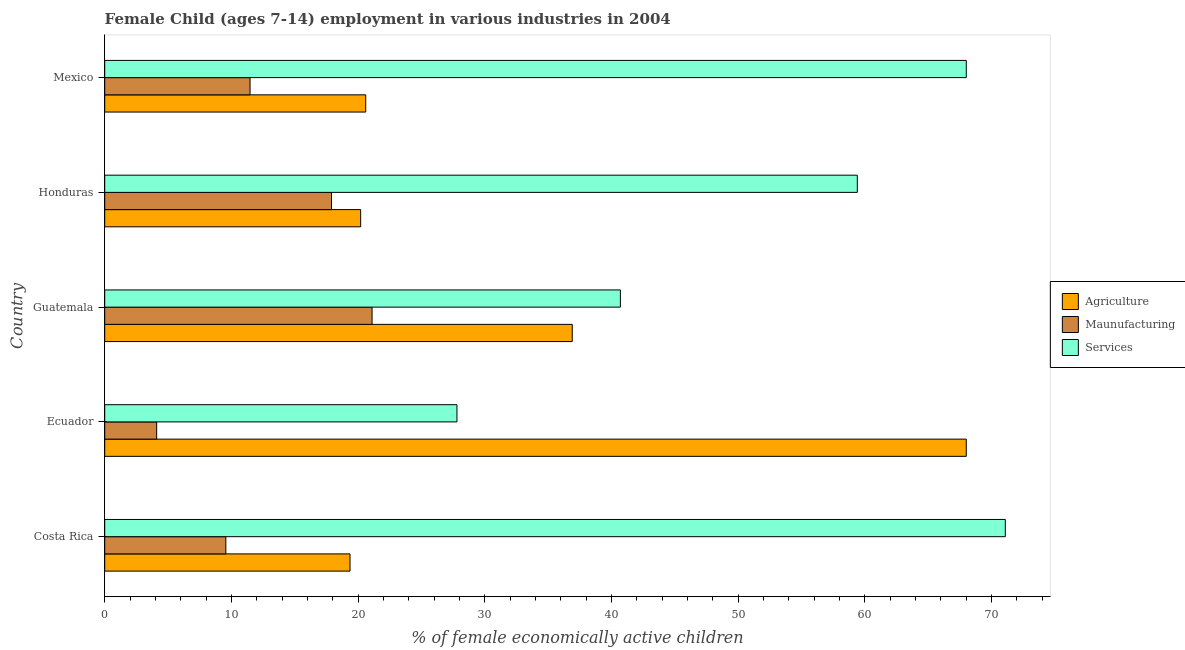How many groups of bars are there?
Offer a terse response. 5. Are the number of bars per tick equal to the number of legend labels?
Make the answer very short. Yes. Are the number of bars on each tick of the Y-axis equal?
Offer a very short reply. Yes. How many bars are there on the 1st tick from the bottom?
Provide a succinct answer. 3. What is the label of the 4th group of bars from the top?
Provide a short and direct response. Ecuador. What is the percentage of economically active children in agriculture in Mexico?
Your answer should be very brief. 20.6. Across all countries, what is the maximum percentage of economically active children in services?
Give a very brief answer. 71.08. Across all countries, what is the minimum percentage of economically active children in services?
Your answer should be compact. 27.8. In which country was the percentage of economically active children in manufacturing maximum?
Give a very brief answer. Guatemala. In which country was the percentage of economically active children in manufacturing minimum?
Your answer should be very brief. Ecuador. What is the total percentage of economically active children in agriculture in the graph?
Your answer should be compact. 165.06. What is the difference between the percentage of economically active children in agriculture in Costa Rica and that in Honduras?
Your answer should be compact. -0.84. What is the difference between the percentage of economically active children in agriculture in Ecuador and the percentage of economically active children in manufacturing in Guatemala?
Make the answer very short. 46.9. What is the average percentage of economically active children in services per country?
Your response must be concise. 53.4. What is the difference between the percentage of economically active children in services and percentage of economically active children in agriculture in Ecuador?
Provide a succinct answer. -40.2. What is the ratio of the percentage of economically active children in services in Costa Rica to that in Honduras?
Provide a succinct answer. 1.2. What is the difference between the highest and the second highest percentage of economically active children in services?
Keep it short and to the point. 3.08. What does the 3rd bar from the top in Guatemala represents?
Give a very brief answer. Agriculture. What does the 3rd bar from the bottom in Honduras represents?
Your answer should be very brief. Services. Are all the bars in the graph horizontal?
Your answer should be very brief. Yes. How many countries are there in the graph?
Your answer should be compact. 5. How many legend labels are there?
Your response must be concise. 3. What is the title of the graph?
Ensure brevity in your answer.  Female Child (ages 7-14) employment in various industries in 2004. Does "Taxes on goods and services" appear as one of the legend labels in the graph?
Your response must be concise. No. What is the label or title of the X-axis?
Provide a succinct answer. % of female economically active children. What is the % of female economically active children in Agriculture in Costa Rica?
Provide a succinct answer. 19.36. What is the % of female economically active children of Maunufacturing in Costa Rica?
Keep it short and to the point. 9.56. What is the % of female economically active children in Services in Costa Rica?
Your answer should be very brief. 71.08. What is the % of female economically active children of Services in Ecuador?
Make the answer very short. 27.8. What is the % of female economically active children of Agriculture in Guatemala?
Your answer should be very brief. 36.9. What is the % of female economically active children of Maunufacturing in Guatemala?
Provide a short and direct response. 21.1. What is the % of female economically active children in Services in Guatemala?
Your response must be concise. 40.7. What is the % of female economically active children of Agriculture in Honduras?
Give a very brief answer. 20.2. What is the % of female economically active children of Services in Honduras?
Your answer should be very brief. 59.4. What is the % of female economically active children of Agriculture in Mexico?
Provide a short and direct response. 20.6. What is the % of female economically active children in Maunufacturing in Mexico?
Your answer should be very brief. 11.47. What is the % of female economically active children in Services in Mexico?
Offer a terse response. 68. Across all countries, what is the maximum % of female economically active children of Agriculture?
Provide a short and direct response. 68. Across all countries, what is the maximum % of female economically active children in Maunufacturing?
Provide a short and direct response. 21.1. Across all countries, what is the maximum % of female economically active children of Services?
Keep it short and to the point. 71.08. Across all countries, what is the minimum % of female economically active children in Agriculture?
Provide a succinct answer. 19.36. Across all countries, what is the minimum % of female economically active children in Maunufacturing?
Provide a short and direct response. 4.1. Across all countries, what is the minimum % of female economically active children in Services?
Your answer should be compact. 27.8. What is the total % of female economically active children in Agriculture in the graph?
Your answer should be very brief. 165.06. What is the total % of female economically active children in Maunufacturing in the graph?
Make the answer very short. 64.13. What is the total % of female economically active children in Services in the graph?
Your answer should be compact. 266.98. What is the difference between the % of female economically active children of Agriculture in Costa Rica and that in Ecuador?
Give a very brief answer. -48.64. What is the difference between the % of female economically active children in Maunufacturing in Costa Rica and that in Ecuador?
Your response must be concise. 5.46. What is the difference between the % of female economically active children in Services in Costa Rica and that in Ecuador?
Give a very brief answer. 43.28. What is the difference between the % of female economically active children of Agriculture in Costa Rica and that in Guatemala?
Offer a very short reply. -17.54. What is the difference between the % of female economically active children in Maunufacturing in Costa Rica and that in Guatemala?
Make the answer very short. -11.54. What is the difference between the % of female economically active children of Services in Costa Rica and that in Guatemala?
Your answer should be very brief. 30.38. What is the difference between the % of female economically active children of Agriculture in Costa Rica and that in Honduras?
Your answer should be very brief. -0.84. What is the difference between the % of female economically active children in Maunufacturing in Costa Rica and that in Honduras?
Offer a terse response. -8.34. What is the difference between the % of female economically active children in Services in Costa Rica and that in Honduras?
Ensure brevity in your answer.  11.68. What is the difference between the % of female economically active children of Agriculture in Costa Rica and that in Mexico?
Your response must be concise. -1.24. What is the difference between the % of female economically active children in Maunufacturing in Costa Rica and that in Mexico?
Your answer should be very brief. -1.91. What is the difference between the % of female economically active children of Services in Costa Rica and that in Mexico?
Your response must be concise. 3.08. What is the difference between the % of female economically active children in Agriculture in Ecuador and that in Guatemala?
Offer a terse response. 31.1. What is the difference between the % of female economically active children in Maunufacturing in Ecuador and that in Guatemala?
Provide a short and direct response. -17. What is the difference between the % of female economically active children in Agriculture in Ecuador and that in Honduras?
Ensure brevity in your answer.  47.8. What is the difference between the % of female economically active children in Maunufacturing in Ecuador and that in Honduras?
Your answer should be very brief. -13.8. What is the difference between the % of female economically active children of Services in Ecuador and that in Honduras?
Offer a terse response. -31.6. What is the difference between the % of female economically active children of Agriculture in Ecuador and that in Mexico?
Provide a succinct answer. 47.4. What is the difference between the % of female economically active children of Maunufacturing in Ecuador and that in Mexico?
Provide a succinct answer. -7.37. What is the difference between the % of female economically active children of Services in Ecuador and that in Mexico?
Offer a very short reply. -40.2. What is the difference between the % of female economically active children in Agriculture in Guatemala and that in Honduras?
Provide a succinct answer. 16.7. What is the difference between the % of female economically active children of Maunufacturing in Guatemala and that in Honduras?
Provide a short and direct response. 3.2. What is the difference between the % of female economically active children of Services in Guatemala and that in Honduras?
Provide a short and direct response. -18.7. What is the difference between the % of female economically active children in Agriculture in Guatemala and that in Mexico?
Provide a succinct answer. 16.3. What is the difference between the % of female economically active children in Maunufacturing in Guatemala and that in Mexico?
Ensure brevity in your answer.  9.63. What is the difference between the % of female economically active children of Services in Guatemala and that in Mexico?
Give a very brief answer. -27.3. What is the difference between the % of female economically active children of Maunufacturing in Honduras and that in Mexico?
Provide a short and direct response. 6.43. What is the difference between the % of female economically active children in Services in Honduras and that in Mexico?
Provide a short and direct response. -8.6. What is the difference between the % of female economically active children in Agriculture in Costa Rica and the % of female economically active children in Maunufacturing in Ecuador?
Provide a short and direct response. 15.26. What is the difference between the % of female economically active children in Agriculture in Costa Rica and the % of female economically active children in Services in Ecuador?
Your answer should be compact. -8.44. What is the difference between the % of female economically active children of Maunufacturing in Costa Rica and the % of female economically active children of Services in Ecuador?
Offer a very short reply. -18.24. What is the difference between the % of female economically active children of Agriculture in Costa Rica and the % of female economically active children of Maunufacturing in Guatemala?
Your response must be concise. -1.74. What is the difference between the % of female economically active children in Agriculture in Costa Rica and the % of female economically active children in Services in Guatemala?
Give a very brief answer. -21.34. What is the difference between the % of female economically active children of Maunufacturing in Costa Rica and the % of female economically active children of Services in Guatemala?
Offer a very short reply. -31.14. What is the difference between the % of female economically active children in Agriculture in Costa Rica and the % of female economically active children in Maunufacturing in Honduras?
Make the answer very short. 1.46. What is the difference between the % of female economically active children of Agriculture in Costa Rica and the % of female economically active children of Services in Honduras?
Your answer should be compact. -40.04. What is the difference between the % of female economically active children of Maunufacturing in Costa Rica and the % of female economically active children of Services in Honduras?
Keep it short and to the point. -49.84. What is the difference between the % of female economically active children in Agriculture in Costa Rica and the % of female economically active children in Maunufacturing in Mexico?
Your response must be concise. 7.89. What is the difference between the % of female economically active children of Agriculture in Costa Rica and the % of female economically active children of Services in Mexico?
Ensure brevity in your answer.  -48.64. What is the difference between the % of female economically active children of Maunufacturing in Costa Rica and the % of female economically active children of Services in Mexico?
Make the answer very short. -58.44. What is the difference between the % of female economically active children of Agriculture in Ecuador and the % of female economically active children of Maunufacturing in Guatemala?
Provide a succinct answer. 46.9. What is the difference between the % of female economically active children in Agriculture in Ecuador and the % of female economically active children in Services in Guatemala?
Ensure brevity in your answer.  27.3. What is the difference between the % of female economically active children of Maunufacturing in Ecuador and the % of female economically active children of Services in Guatemala?
Keep it short and to the point. -36.6. What is the difference between the % of female economically active children in Agriculture in Ecuador and the % of female economically active children in Maunufacturing in Honduras?
Your answer should be compact. 50.1. What is the difference between the % of female economically active children of Maunufacturing in Ecuador and the % of female economically active children of Services in Honduras?
Ensure brevity in your answer.  -55.3. What is the difference between the % of female economically active children in Agriculture in Ecuador and the % of female economically active children in Maunufacturing in Mexico?
Your answer should be very brief. 56.53. What is the difference between the % of female economically active children in Agriculture in Ecuador and the % of female economically active children in Services in Mexico?
Offer a terse response. 0. What is the difference between the % of female economically active children of Maunufacturing in Ecuador and the % of female economically active children of Services in Mexico?
Ensure brevity in your answer.  -63.9. What is the difference between the % of female economically active children of Agriculture in Guatemala and the % of female economically active children of Maunufacturing in Honduras?
Give a very brief answer. 19. What is the difference between the % of female economically active children of Agriculture in Guatemala and the % of female economically active children of Services in Honduras?
Your answer should be very brief. -22.5. What is the difference between the % of female economically active children of Maunufacturing in Guatemala and the % of female economically active children of Services in Honduras?
Provide a short and direct response. -38.3. What is the difference between the % of female economically active children in Agriculture in Guatemala and the % of female economically active children in Maunufacturing in Mexico?
Your response must be concise. 25.43. What is the difference between the % of female economically active children of Agriculture in Guatemala and the % of female economically active children of Services in Mexico?
Your response must be concise. -31.1. What is the difference between the % of female economically active children of Maunufacturing in Guatemala and the % of female economically active children of Services in Mexico?
Your answer should be very brief. -46.9. What is the difference between the % of female economically active children of Agriculture in Honduras and the % of female economically active children of Maunufacturing in Mexico?
Provide a succinct answer. 8.73. What is the difference between the % of female economically active children in Agriculture in Honduras and the % of female economically active children in Services in Mexico?
Your response must be concise. -47.8. What is the difference between the % of female economically active children of Maunufacturing in Honduras and the % of female economically active children of Services in Mexico?
Provide a succinct answer. -50.1. What is the average % of female economically active children of Agriculture per country?
Provide a short and direct response. 33.01. What is the average % of female economically active children of Maunufacturing per country?
Offer a terse response. 12.83. What is the average % of female economically active children in Services per country?
Offer a very short reply. 53.4. What is the difference between the % of female economically active children of Agriculture and % of female economically active children of Maunufacturing in Costa Rica?
Offer a terse response. 9.8. What is the difference between the % of female economically active children in Agriculture and % of female economically active children in Services in Costa Rica?
Your response must be concise. -51.72. What is the difference between the % of female economically active children of Maunufacturing and % of female economically active children of Services in Costa Rica?
Give a very brief answer. -61.52. What is the difference between the % of female economically active children of Agriculture and % of female economically active children of Maunufacturing in Ecuador?
Your response must be concise. 63.9. What is the difference between the % of female economically active children of Agriculture and % of female economically active children of Services in Ecuador?
Offer a terse response. 40.2. What is the difference between the % of female economically active children in Maunufacturing and % of female economically active children in Services in Ecuador?
Keep it short and to the point. -23.7. What is the difference between the % of female economically active children in Agriculture and % of female economically active children in Maunufacturing in Guatemala?
Make the answer very short. 15.8. What is the difference between the % of female economically active children in Maunufacturing and % of female economically active children in Services in Guatemala?
Your response must be concise. -19.6. What is the difference between the % of female economically active children of Agriculture and % of female economically active children of Services in Honduras?
Your answer should be very brief. -39.2. What is the difference between the % of female economically active children of Maunufacturing and % of female economically active children of Services in Honduras?
Provide a short and direct response. -41.5. What is the difference between the % of female economically active children in Agriculture and % of female economically active children in Maunufacturing in Mexico?
Keep it short and to the point. 9.13. What is the difference between the % of female economically active children in Agriculture and % of female economically active children in Services in Mexico?
Your answer should be very brief. -47.4. What is the difference between the % of female economically active children in Maunufacturing and % of female economically active children in Services in Mexico?
Keep it short and to the point. -56.53. What is the ratio of the % of female economically active children in Agriculture in Costa Rica to that in Ecuador?
Provide a short and direct response. 0.28. What is the ratio of the % of female economically active children of Maunufacturing in Costa Rica to that in Ecuador?
Offer a very short reply. 2.33. What is the ratio of the % of female economically active children of Services in Costa Rica to that in Ecuador?
Offer a very short reply. 2.56. What is the ratio of the % of female economically active children in Agriculture in Costa Rica to that in Guatemala?
Offer a very short reply. 0.52. What is the ratio of the % of female economically active children of Maunufacturing in Costa Rica to that in Guatemala?
Provide a short and direct response. 0.45. What is the ratio of the % of female economically active children in Services in Costa Rica to that in Guatemala?
Keep it short and to the point. 1.75. What is the ratio of the % of female economically active children in Agriculture in Costa Rica to that in Honduras?
Give a very brief answer. 0.96. What is the ratio of the % of female economically active children of Maunufacturing in Costa Rica to that in Honduras?
Provide a succinct answer. 0.53. What is the ratio of the % of female economically active children of Services in Costa Rica to that in Honduras?
Provide a short and direct response. 1.2. What is the ratio of the % of female economically active children in Agriculture in Costa Rica to that in Mexico?
Offer a terse response. 0.94. What is the ratio of the % of female economically active children in Maunufacturing in Costa Rica to that in Mexico?
Provide a succinct answer. 0.83. What is the ratio of the % of female economically active children in Services in Costa Rica to that in Mexico?
Ensure brevity in your answer.  1.05. What is the ratio of the % of female economically active children in Agriculture in Ecuador to that in Guatemala?
Keep it short and to the point. 1.84. What is the ratio of the % of female economically active children in Maunufacturing in Ecuador to that in Guatemala?
Give a very brief answer. 0.19. What is the ratio of the % of female economically active children in Services in Ecuador to that in Guatemala?
Your answer should be very brief. 0.68. What is the ratio of the % of female economically active children of Agriculture in Ecuador to that in Honduras?
Keep it short and to the point. 3.37. What is the ratio of the % of female economically active children in Maunufacturing in Ecuador to that in Honduras?
Your answer should be very brief. 0.23. What is the ratio of the % of female economically active children in Services in Ecuador to that in Honduras?
Offer a terse response. 0.47. What is the ratio of the % of female economically active children of Agriculture in Ecuador to that in Mexico?
Give a very brief answer. 3.3. What is the ratio of the % of female economically active children of Maunufacturing in Ecuador to that in Mexico?
Offer a very short reply. 0.36. What is the ratio of the % of female economically active children of Services in Ecuador to that in Mexico?
Provide a short and direct response. 0.41. What is the ratio of the % of female economically active children in Agriculture in Guatemala to that in Honduras?
Provide a short and direct response. 1.83. What is the ratio of the % of female economically active children in Maunufacturing in Guatemala to that in Honduras?
Keep it short and to the point. 1.18. What is the ratio of the % of female economically active children of Services in Guatemala to that in Honduras?
Offer a very short reply. 0.69. What is the ratio of the % of female economically active children in Agriculture in Guatemala to that in Mexico?
Provide a succinct answer. 1.79. What is the ratio of the % of female economically active children of Maunufacturing in Guatemala to that in Mexico?
Your response must be concise. 1.84. What is the ratio of the % of female economically active children of Services in Guatemala to that in Mexico?
Keep it short and to the point. 0.6. What is the ratio of the % of female economically active children in Agriculture in Honduras to that in Mexico?
Offer a terse response. 0.98. What is the ratio of the % of female economically active children of Maunufacturing in Honduras to that in Mexico?
Ensure brevity in your answer.  1.56. What is the ratio of the % of female economically active children in Services in Honduras to that in Mexico?
Your response must be concise. 0.87. What is the difference between the highest and the second highest % of female economically active children of Agriculture?
Give a very brief answer. 31.1. What is the difference between the highest and the second highest % of female economically active children of Maunufacturing?
Your answer should be compact. 3.2. What is the difference between the highest and the second highest % of female economically active children in Services?
Ensure brevity in your answer.  3.08. What is the difference between the highest and the lowest % of female economically active children of Agriculture?
Offer a terse response. 48.64. What is the difference between the highest and the lowest % of female economically active children of Maunufacturing?
Make the answer very short. 17. What is the difference between the highest and the lowest % of female economically active children of Services?
Provide a short and direct response. 43.28. 